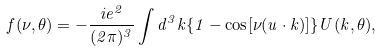Convert formula to latex. <formula><loc_0><loc_0><loc_500><loc_500>f ( \nu , \theta ) = - \frac { i e ^ { 2 } } { ( 2 \pi ) ^ { 3 } } \int d ^ { 3 } k \{ 1 - \cos [ \nu ( u \cdot k ) ] \} U ( k , \theta ) ,</formula> 